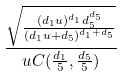Convert formula to latex. <formula><loc_0><loc_0><loc_500><loc_500>\frac { \sqrt { \frac { ( d _ { 1 } u ) ^ { d _ { 1 } } d _ { 5 } ^ { d _ { 5 } } } { ( d _ { 1 } u + d _ { 5 } ) ^ { d _ { 1 } + d _ { 5 } } } } } { u C ( \frac { d _ { 1 } } { 5 } , \frac { d _ { 5 } } { 5 } ) }</formula> 